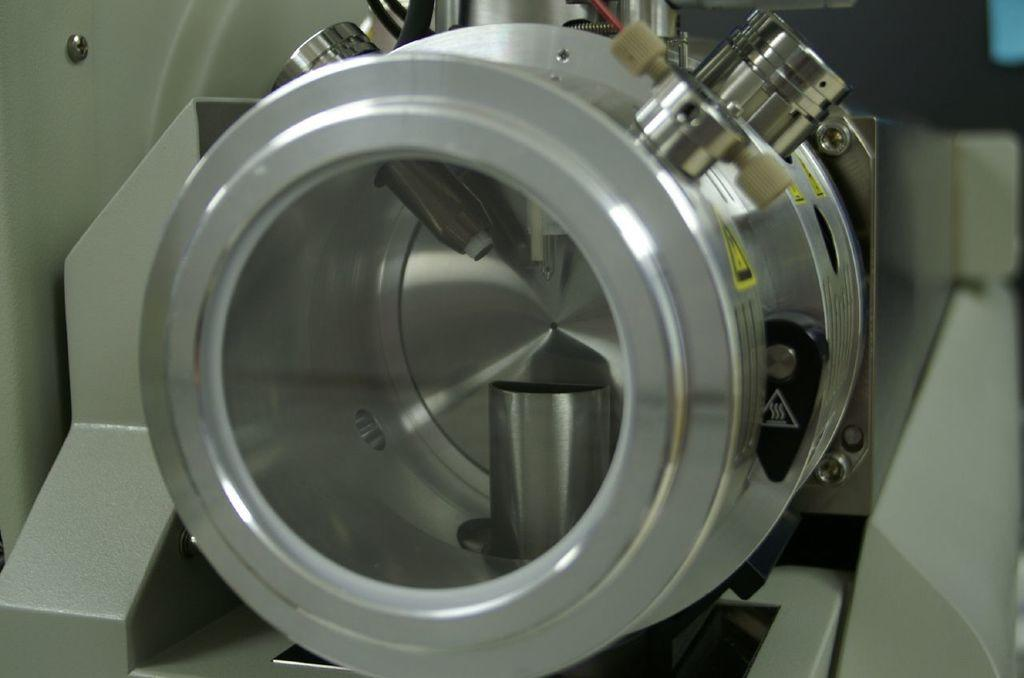What is the main subject of the image? The main subject of the image is an object that looks like a machine. Can you describe the objects in the background of the image? Unfortunately, the provided facts do not give any information about the objects in the background. How does the machine stretch in the image? There is no indication in the image that the machine is stretching or has the ability to stretch. 